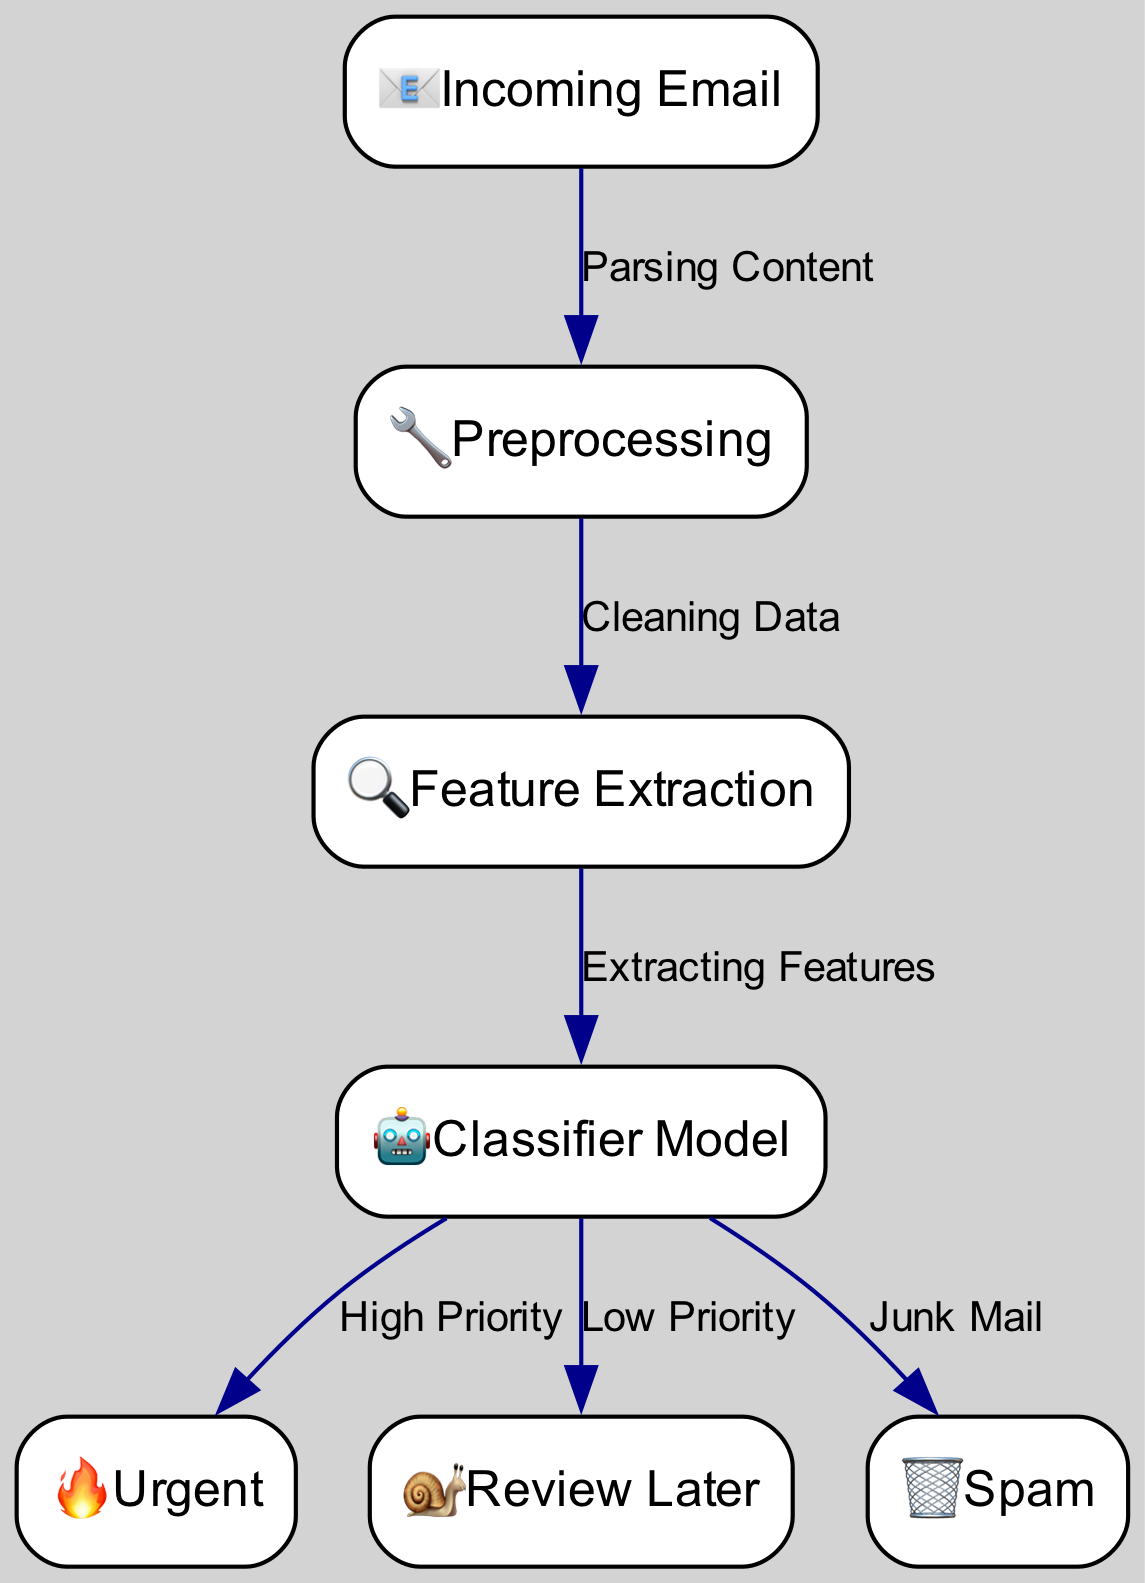What is the first node in the diagram? The first node in the diagram is the "Incoming Email" node, represented by the icon 📧. It is the starting point for processing client emails.
Answer: Incoming Email How many categories are available for email classification? The diagram shows three categories for email classification: "Urgent," "Review Later," and "Spam." This can be determined by counting the categorized nodes connected to the classification model.
Answer: Three Which node represents the process of preparing the email data? The "Preprocessing" node is the one that represents the preparation of email data. This step involves tasks like parsing and cleaning to make the data suitable for analysis.
Answer: Preprocessing What is the final output of the classification model? The final outputs of the classification model are three categories, which are "Urgent," "Review Later," and "Spam." Each category is linked to the classification model as its output.
Answer: Urgent, Review Later, Spam Which category is linked to the classifier model as 'High Priority'? The "Urgent" category is associated with the classifier model as 'High Priority.' This indicates that when the classifier deems an email urgent, it directs it to this category.
Answer: Urgent What type of icon represents the 'Spam' category? The icon for the 'Spam' category is a trash can, which visually indicates that these emails are unwanted and should be discarded.
Answer: Trash can What is the relationship between the "Cleaning Data" and "Feature Extraction" processes? The relationship is that "Cleaning Data" occurs before "Feature Extraction" in the workflow. "Cleaning Data" is necessary to prepare the raw email data for extracting relevant features.
Answer: Precedes How many edges connect the 'Classifier Model' node to different categories? There are three edges that connect the 'Classifier Model' node to the different categories: 'Urgent,' 'Review Later,' and 'Spam,' demonstrating its role in determining the type of email.
Answer: Three What does the fire icon in the diagram symbolize? The fire icon symbolizes the 'Urgent' category, indicating that emails in this category require immediate attention.
Answer: Urgent 